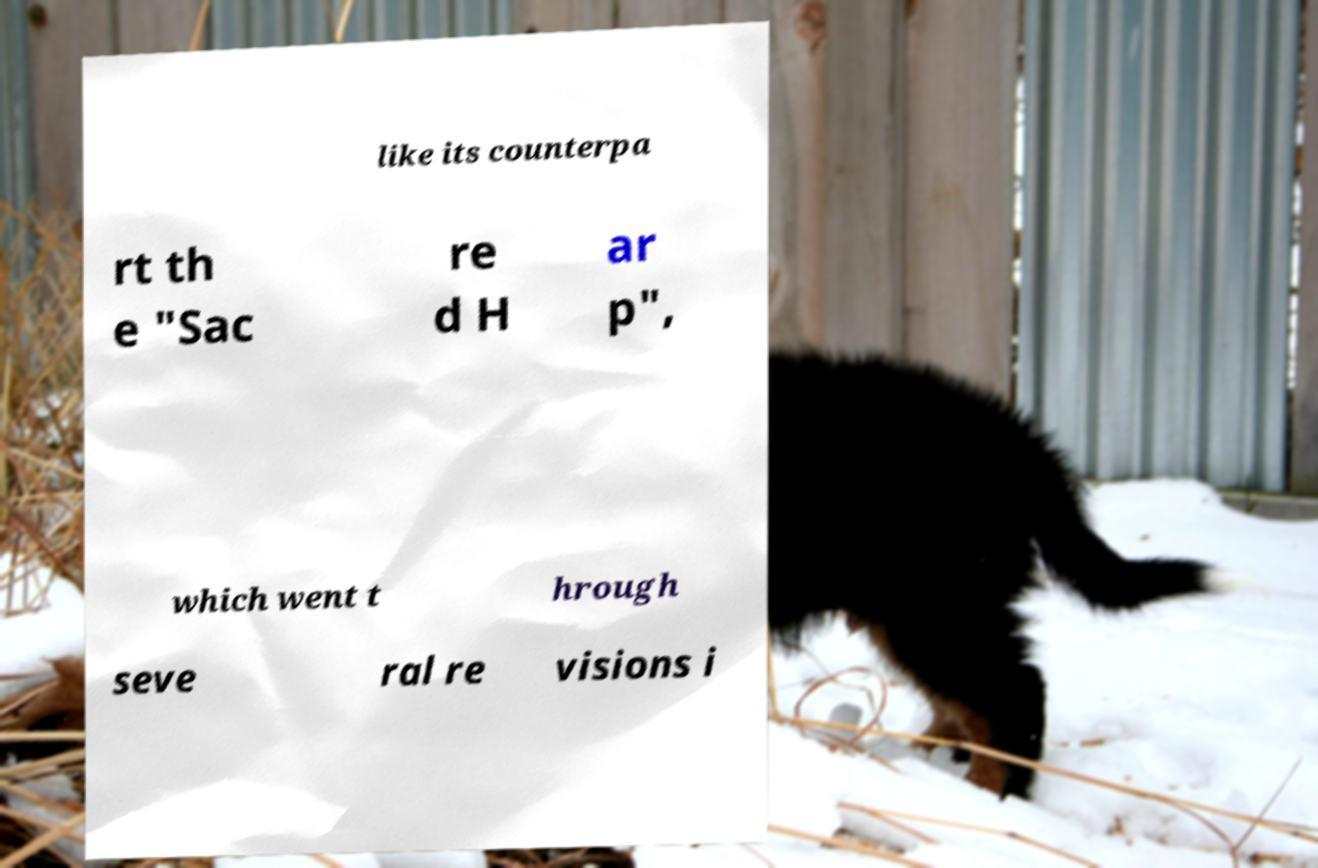Please identify and transcribe the text found in this image. like its counterpa rt th e "Sac re d H ar p", which went t hrough seve ral re visions i 